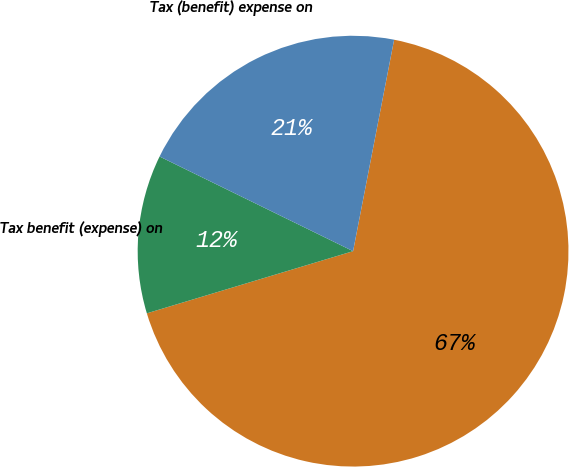Convert chart to OTSL. <chart><loc_0><loc_0><loc_500><loc_500><pie_chart><ecel><fcel>Tax benefit (expense) on<fcel>Tax (benefit) expense on<nl><fcel>67.29%<fcel>11.9%<fcel>20.81%<nl></chart> 